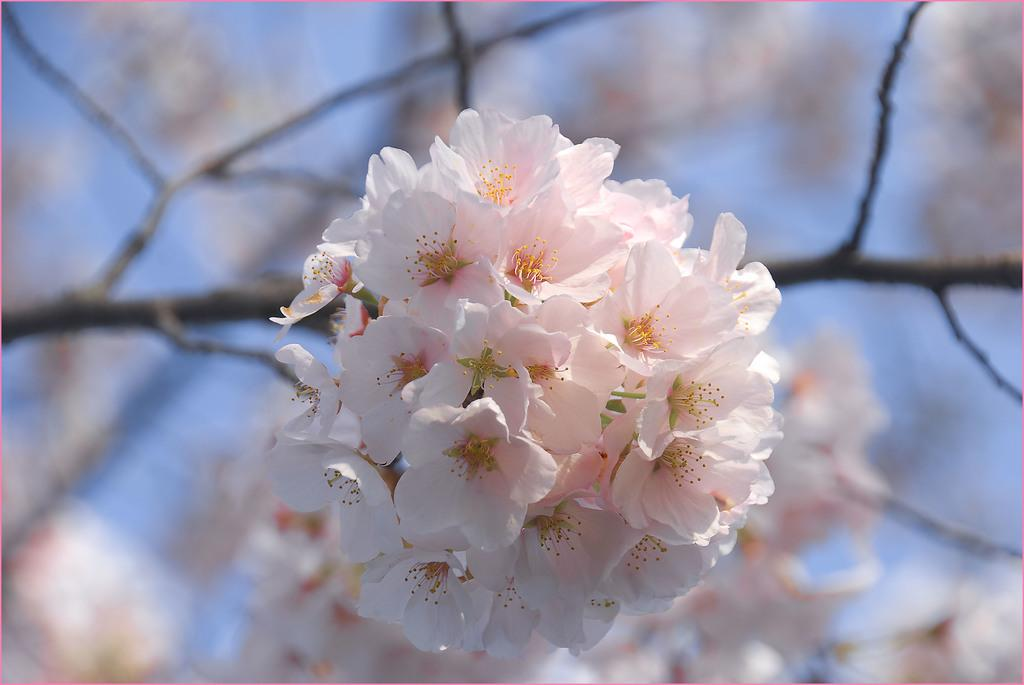What type of plant is visible in the image? There are flowers on a branch in the image. Can you describe the background of the image? There is a plant visible in the background of the image. What type of glass is being used to calculate the number of petals on the flowers? There is no glass or calculator present in the image, and the number of petals on the flowers is not mentioned. 